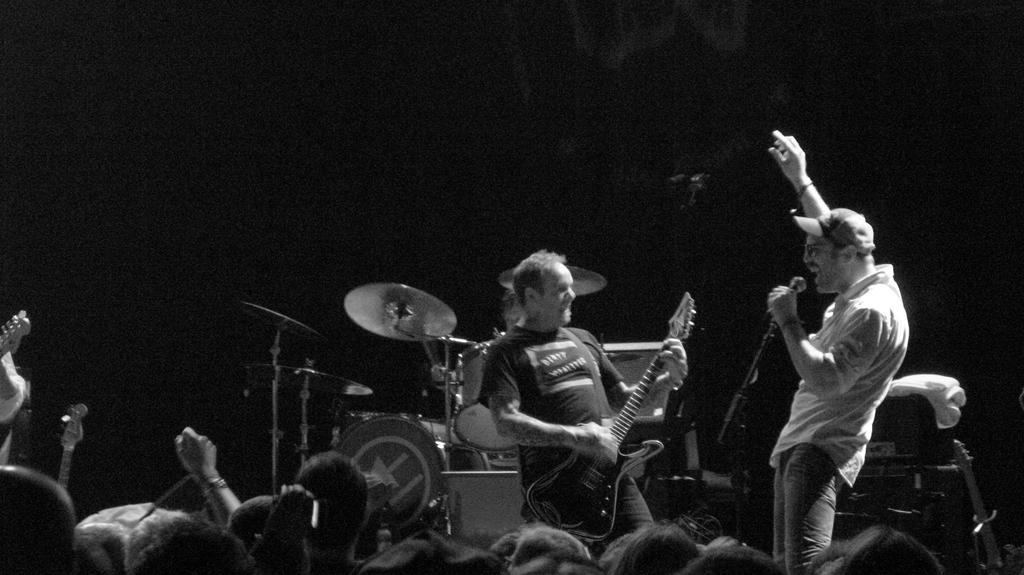Can you describe this image briefly? In this image, we can see 2 peoples are standing. At the bottom, there are so many human heads we can see. The left side, there is a human hand. In the middle of the image, we can found musical instrument. The man in the middle, he hold a guitar in his hand. The right side of the image, man hold a microphone in his hand and he wear a cap on his head. 